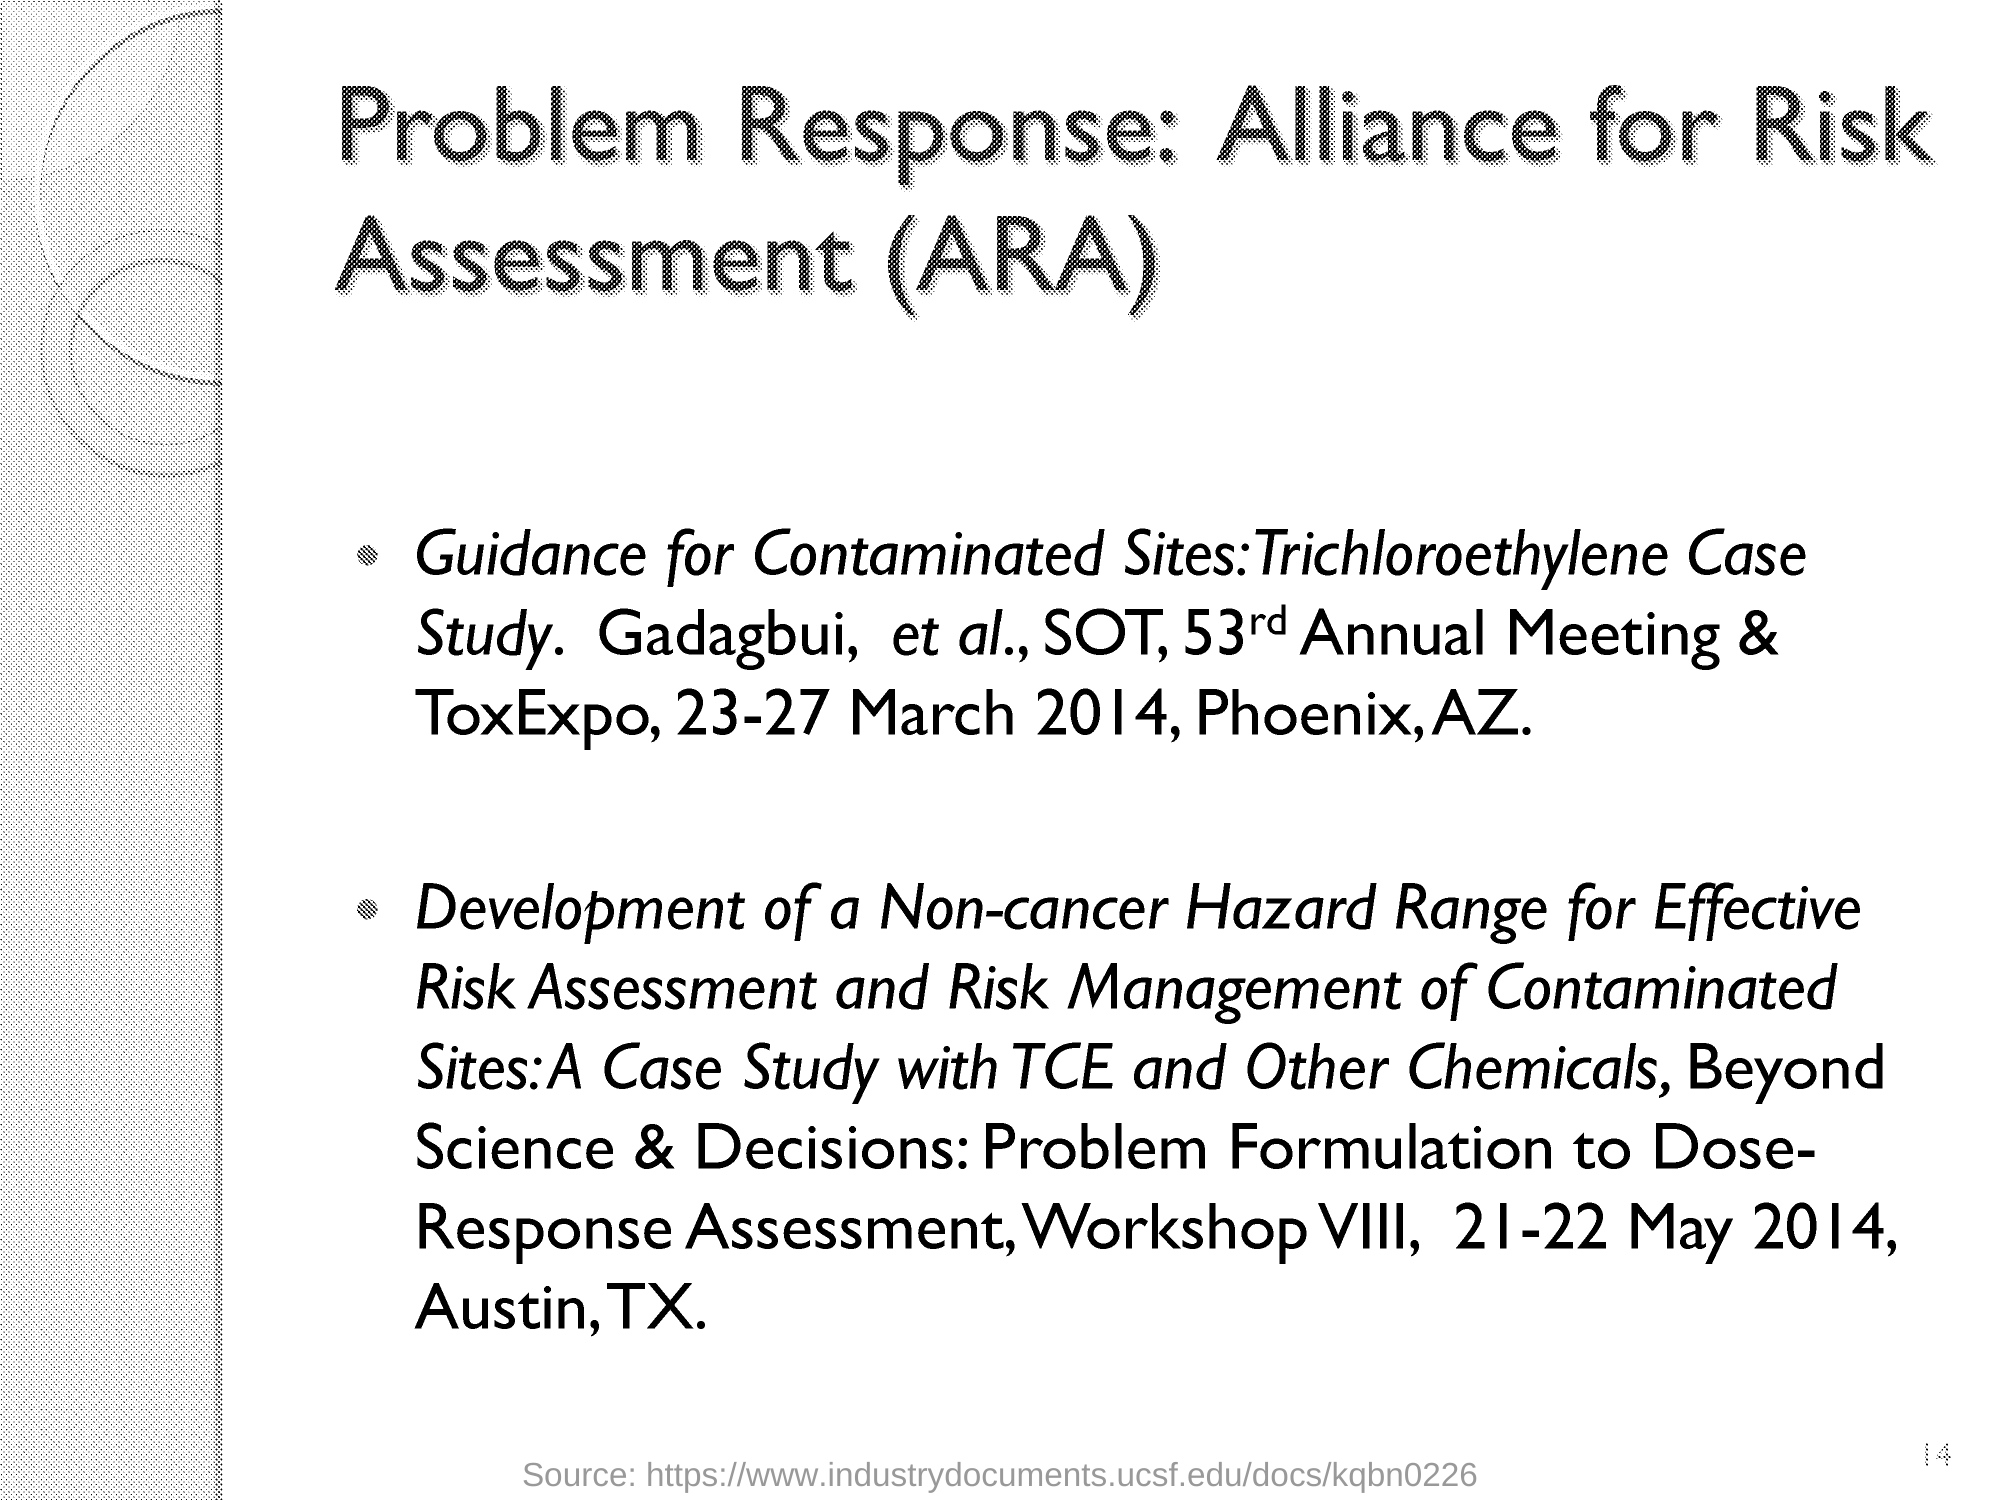Mention a couple of crucial points in this snapshot. Alliance for Risk Assessment" is the full form of ARA. 